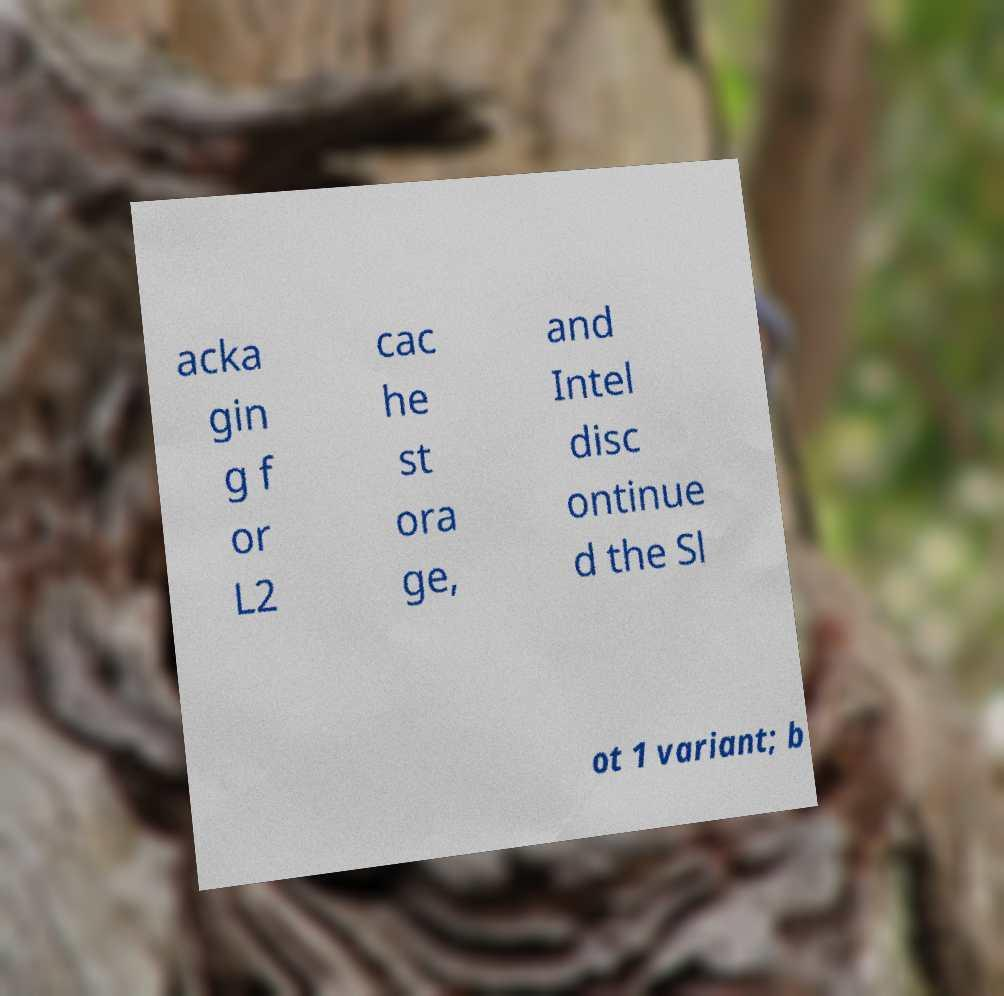For documentation purposes, I need the text within this image transcribed. Could you provide that? acka gin g f or L2 cac he st ora ge, and Intel disc ontinue d the Sl ot 1 variant; b 